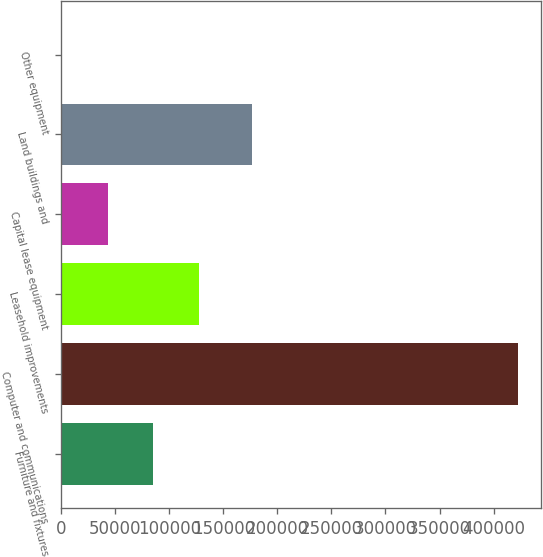<chart> <loc_0><loc_0><loc_500><loc_500><bar_chart><fcel>Furniture and fixtures<fcel>Computer and communications<fcel>Leasehold improvements<fcel>Capital lease equipment<fcel>Land buildings and<fcel>Other equipment<nl><fcel>85329.6<fcel>422716<fcel>127503<fcel>43156.3<fcel>176216<fcel>983<nl></chart> 